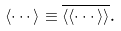Convert formula to latex. <formula><loc_0><loc_0><loc_500><loc_500>\langle \cdots \rangle \equiv \overline { \langle \langle \cdots \rangle \rangle } .</formula> 